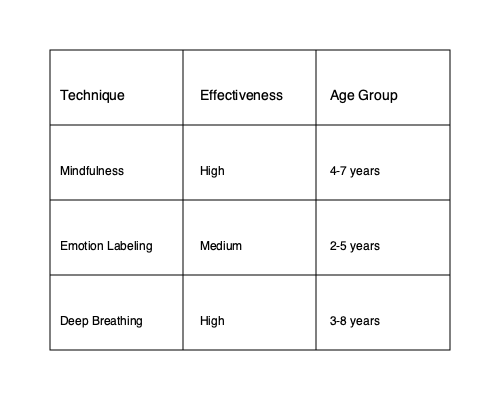Based on the matrix diagram provided, which emotional regulation technique has the highest effectiveness rating and is suitable for the widest age range of children? To answer this question, we need to analyze the information presented in the matrix diagram:

1. Identify the techniques and their effectiveness:
   - Mindfulness: High effectiveness
   - Emotion Labeling: Medium effectiveness
   - Deep Breathing: High effectiveness

2. Determine the age ranges for each technique:
   - Mindfulness: 4-7 years (span of 3 years)
   - Emotion Labeling: 2-5 years (span of 3 years)
   - Deep Breathing: 3-8 years (span of 5 years)

3. Compare the effectiveness and age ranges:
   - Both Mindfulness and Deep Breathing have high effectiveness ratings.
   - Deep Breathing has the widest age range (5 years) compared to Mindfulness and Emotion Labeling (both 3 years).

4. Conclude based on the criteria:
   The technique with the highest effectiveness rating and suitable for the widest age range is Deep Breathing.
Answer: Deep Breathing 